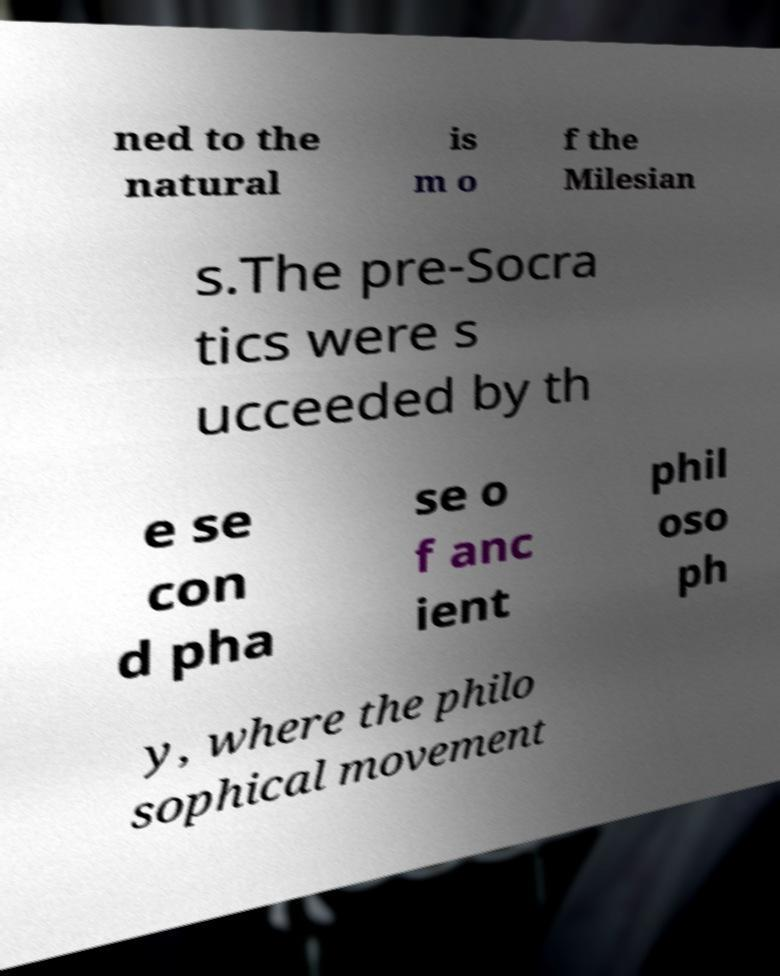Please identify and transcribe the text found in this image. ned to the natural is m o f the Milesian s.The pre-Socra tics were s ucceeded by th e se con d pha se o f anc ient phil oso ph y, where the philo sophical movement 